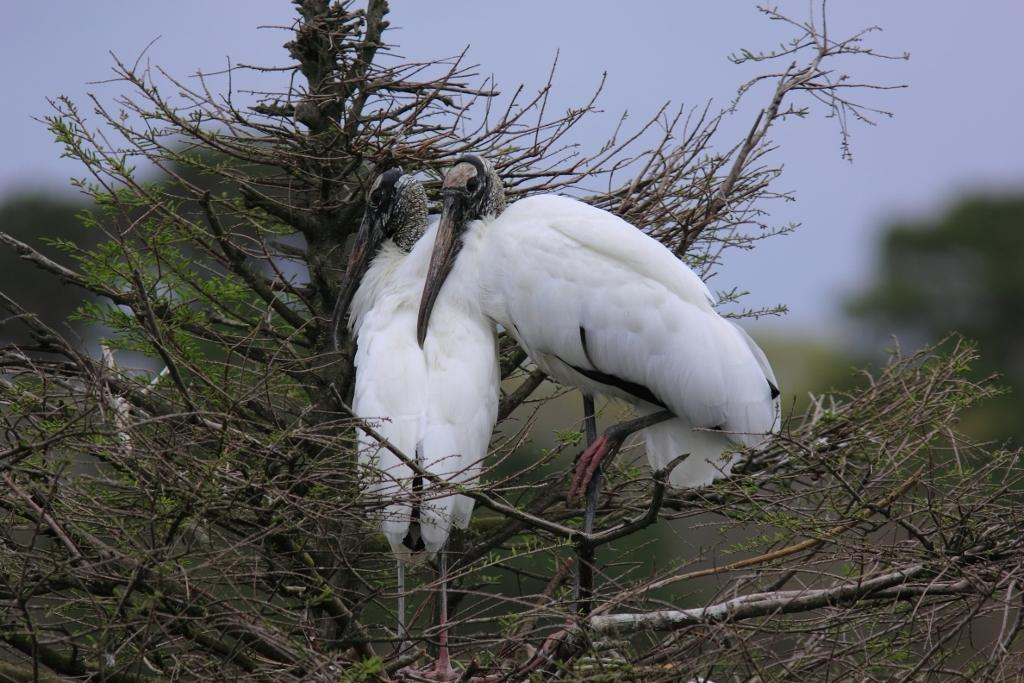How many birds are present in the image? There are two birds in the image. Where are the birds located? The birds are on a tree. Can you describe the background of the image? The background of the image is blurred. What type of account does the owl have in the image? There is no owl present in the image, and therefore no account can be associated with it. 